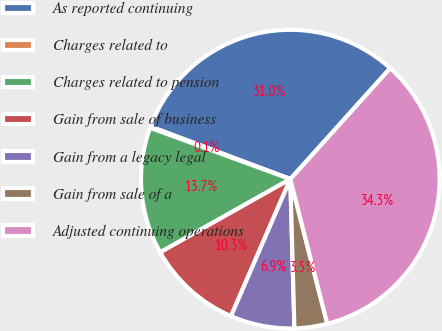<chart> <loc_0><loc_0><loc_500><loc_500><pie_chart><fcel>As reported continuing<fcel>Charges related to<fcel>Charges related to pension<fcel>Gain from sale of business<fcel>Gain from a legacy legal<fcel>Gain from sale of a<fcel>Adjusted continuing operations<nl><fcel>30.95%<fcel>0.14%<fcel>13.74%<fcel>10.34%<fcel>6.94%<fcel>3.54%<fcel>34.35%<nl></chart> 